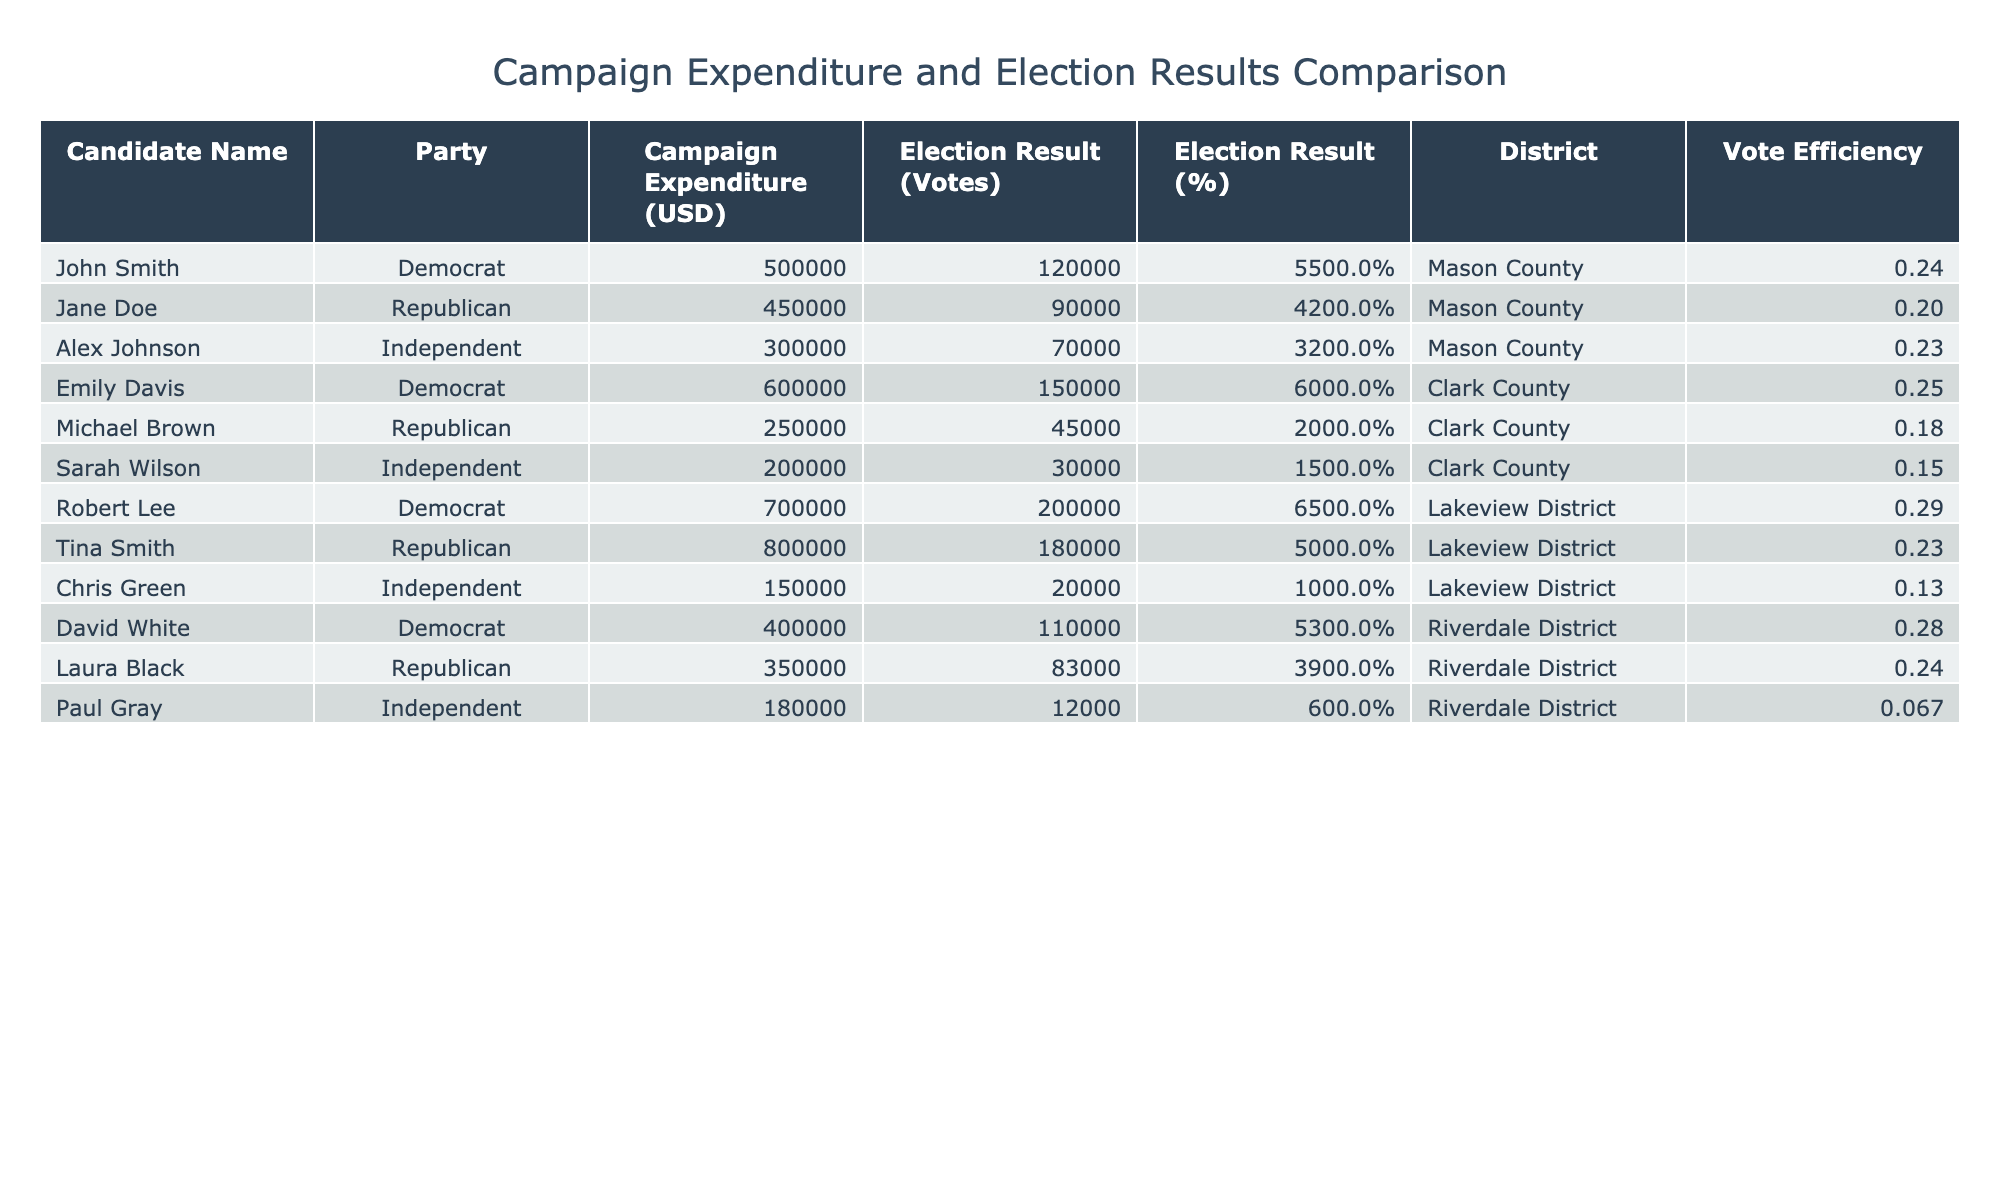What is the highest campaign expenditure in the table? By looking through the 'Campaign Expenditure (USD)' column, we see that Robert Lee's expenditure of 700,000 is the highest among all candidates.
Answer: 700,000 Who received the lowest number of votes? From the 'Election Result (Votes)' column, we find that Paul Gray received the lowest number of votes at 12,000, which is factually the smallest number listed.
Answer: 12,000 What is the total campaign expenditure of the Democrat candidates? To calculate this, we sum the campaign expenditures of all Democrat candidates: 500,000 + 600,000 + 700,000 + 400,000 = 2,200,000. Therefore, the total is 2,200,000.
Answer: 2,200,000 Is it true that the Independent candidates have a higher average vote percentage than the Republican candidates? First, we find the vote percentages for Independents: 32, 15, and 6, averaging (32 + 15 + 6) / 3 = 17.67%. Then for Republicans: 42, 20, and 39, averaging (42 + 20 + 39) / 3 = 33.67%. Since 17.67% is less than 33.67%, the statement is false.
Answer: False What is the vote efficiency of Emily Davis? To find vote efficiency, we divide her votes by her campaign expenditure: 150,000 votes / 600,000 dollars = 0.25. This means for every dollar spent, she received approximately 0.25 votes.
Answer: 0.25 